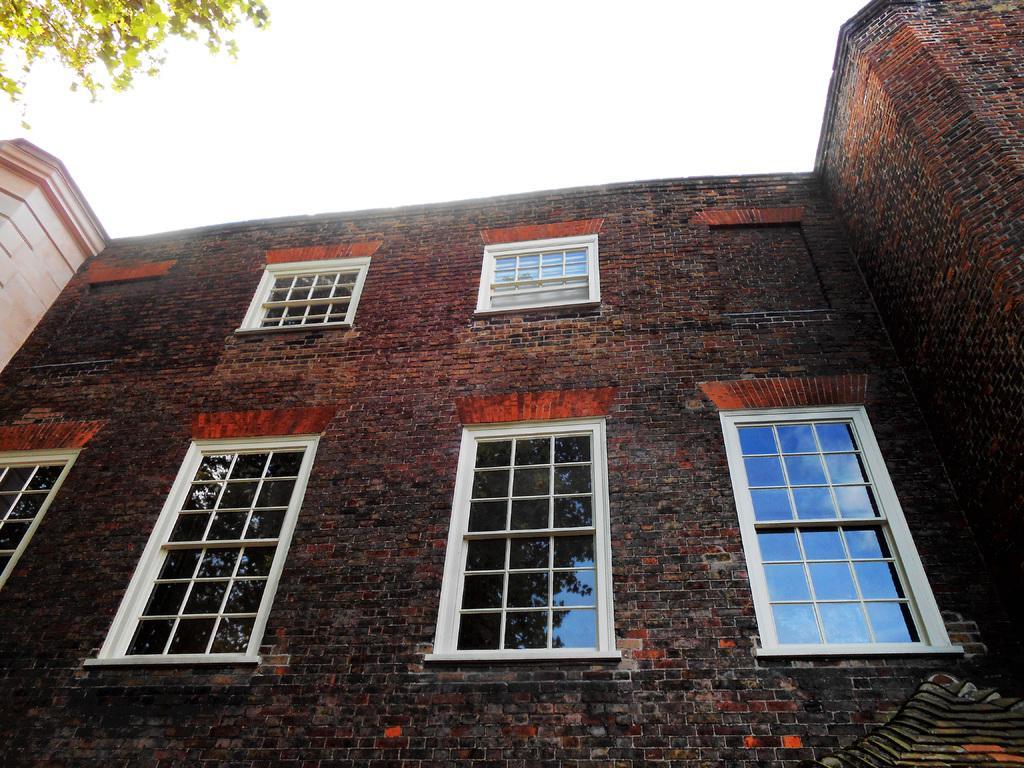Can you describe this image briefly? In this image there is a building in the bottom of this image as we can see there are some windows in middle of this building. There is a sky on the top of this image and there are some leaves on the top left side of this image. 